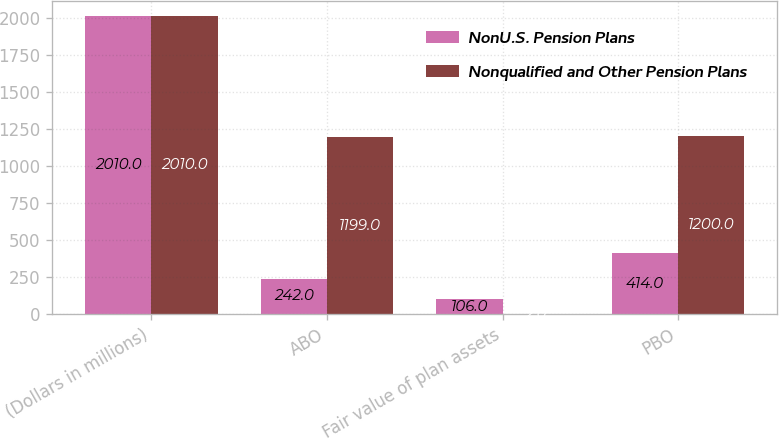Convert chart to OTSL. <chart><loc_0><loc_0><loc_500><loc_500><stacked_bar_chart><ecel><fcel>(Dollars in millions)<fcel>ABO<fcel>Fair value of plan assets<fcel>PBO<nl><fcel>NonU.S. Pension Plans<fcel>2010<fcel>242<fcel>106<fcel>414<nl><fcel>Nonqualified and Other Pension Plans<fcel>2010<fcel>1199<fcel>2<fcel>1200<nl></chart> 